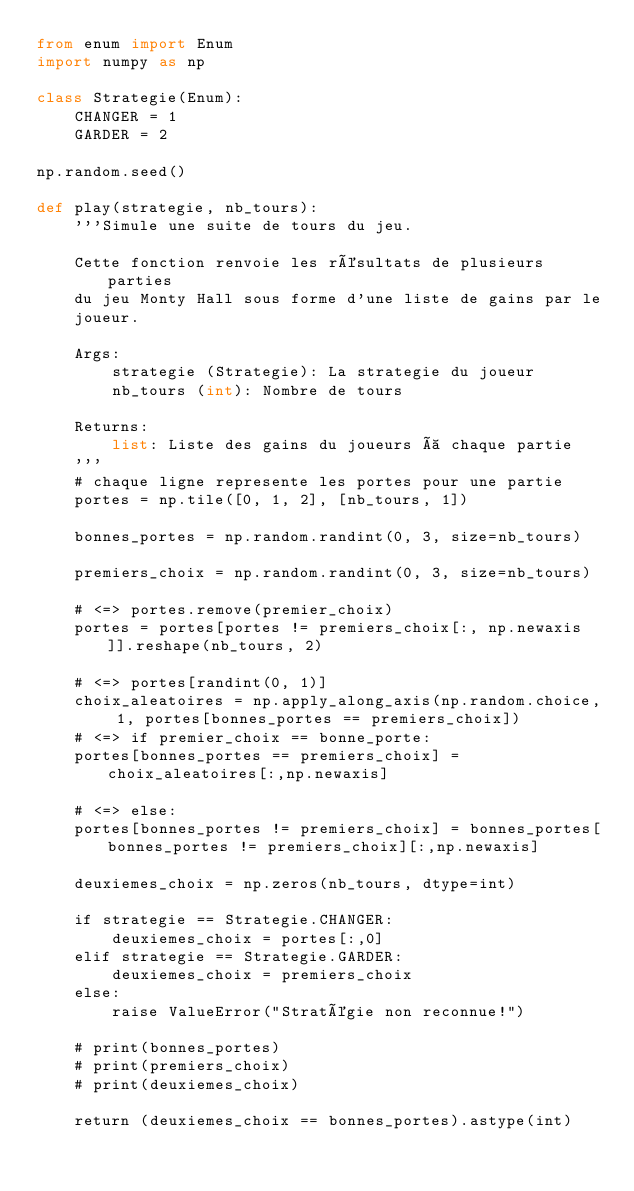Convert code to text. <code><loc_0><loc_0><loc_500><loc_500><_Python_>from enum import Enum
import numpy as np

class Strategie(Enum):
    CHANGER = 1
    GARDER = 2

np.random.seed()

def play(strategie, nb_tours):
    '''Simule une suite de tours du jeu.

    Cette fonction renvoie les résultats de plusieurs parties
    du jeu Monty Hall sous forme d'une liste de gains par le
    joueur.

    Args:
        strategie (Strategie): La strategie du joueur
        nb_tours (int): Nombre de tours

    Returns:
        list: Liste des gains du joueurs à chaque partie
    '''
	# chaque ligne represente les portes pour une partie
    portes = np.tile([0, 1, 2], [nb_tours, 1])

    bonnes_portes = np.random.randint(0, 3, size=nb_tours)

    premiers_choix = np.random.randint(0, 3, size=nb_tours)

    # <=> portes.remove(premier_choix)
    portes = portes[portes != premiers_choix[:, np.newaxis]].reshape(nb_tours, 2)

	# <=> portes[randint(0, 1)]
    choix_aleatoires = np.apply_along_axis(np.random.choice, 1, portes[bonnes_portes == premiers_choix])
    # <=> if premier_choix == bonne_porte:
    portes[bonnes_portes == premiers_choix] = choix_aleatoires[:,np.newaxis]

    # <=> else:
    portes[bonnes_portes != premiers_choix] = bonnes_portes[bonnes_portes != premiers_choix][:,np.newaxis]

    deuxiemes_choix = np.zeros(nb_tours, dtype=int)

    if strategie == Strategie.CHANGER:
        deuxiemes_choix = portes[:,0]
    elif strategie == Strategie.GARDER:
        deuxiemes_choix = premiers_choix
    else:
        raise ValueError("Stratégie non reconnue!")

    # print(bonnes_portes)
    # print(premiers_choix)
    # print(deuxiemes_choix)

    return (deuxiemes_choix == bonnes_portes).astype(int)</code> 